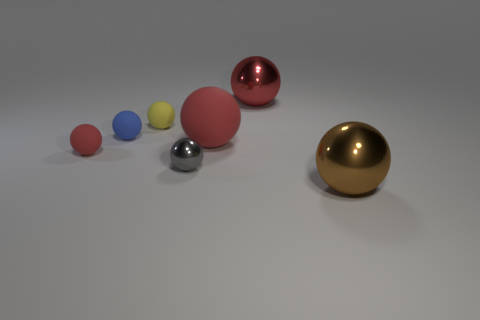Subtract all red spheres. How many were subtracted if there are1red spheres left? 2 Subtract all green cylinders. How many red spheres are left? 3 Subtract all small red spheres. How many spheres are left? 6 Subtract 1 spheres. How many spheres are left? 6 Subtract all gray spheres. How many spheres are left? 6 Subtract all gray spheres. Subtract all green cylinders. How many spheres are left? 6 Add 2 small gray cylinders. How many objects exist? 9 Subtract 0 green cubes. How many objects are left? 7 Subtract all gray spheres. Subtract all small brown shiny things. How many objects are left? 6 Add 1 large red shiny things. How many large red shiny things are left? 2 